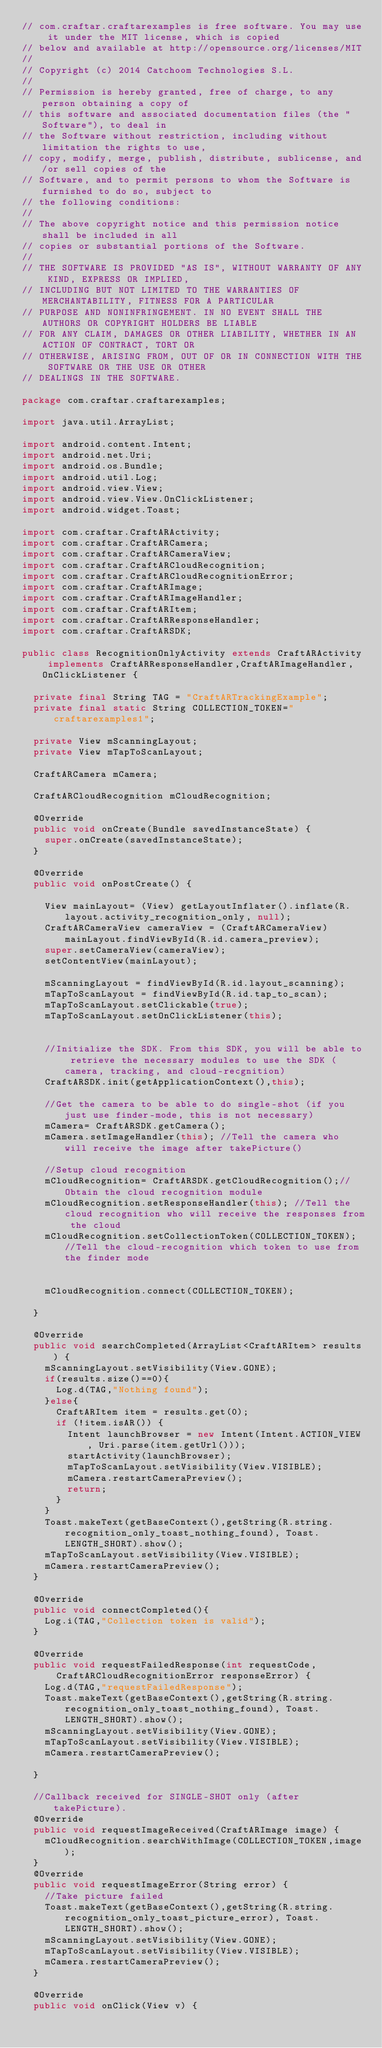Convert code to text. <code><loc_0><loc_0><loc_500><loc_500><_Java_>// com.craftar.craftarexamples is free software. You may use it under the MIT license, which is copied
// below and available at http://opensource.org/licenses/MIT
//
// Copyright (c) 2014 Catchoom Technologies S.L.
//
// Permission is hereby granted, free of charge, to any person obtaining a copy of
// this software and associated documentation files (the "Software"), to deal in
// the Software without restriction, including without limitation the rights to use,
// copy, modify, merge, publish, distribute, sublicense, and/or sell copies of the
// Software, and to permit persons to whom the Software is furnished to do so, subject to
// the following conditions:
//
// The above copyright notice and this permission notice shall be included in all
// copies or substantial portions of the Software.
//
// THE SOFTWARE IS PROVIDED "AS IS", WITHOUT WARRANTY OF ANY KIND, EXPRESS OR IMPLIED,
// INCLUDING BUT NOT LIMITED TO THE WARRANTIES OF MERCHANTABILITY, FITNESS FOR A PARTICULAR
// PURPOSE AND NONINFRINGEMENT. IN NO EVENT SHALL THE AUTHORS OR COPYRIGHT HOLDERS BE LIABLE
// FOR ANY CLAIM, DAMAGES OR OTHER LIABILITY, WHETHER IN AN ACTION OF CONTRACT, TORT OR
// OTHERWISE, ARISING FROM, OUT OF OR IN CONNECTION WITH THE SOFTWARE OR THE USE OR OTHER
// DEALINGS IN THE SOFTWARE.

package com.craftar.craftarexamples;

import java.util.ArrayList;

import android.content.Intent;
import android.net.Uri;
import android.os.Bundle;
import android.util.Log;
import android.view.View;
import android.view.View.OnClickListener;
import android.widget.Toast;

import com.craftar.CraftARActivity;
import com.craftar.CraftARCamera;
import com.craftar.CraftARCameraView;
import com.craftar.CraftARCloudRecognition;
import com.craftar.CraftARCloudRecognitionError;
import com.craftar.CraftARImage;
import com.craftar.CraftARImageHandler;
import com.craftar.CraftARItem;
import com.craftar.CraftARResponseHandler;
import com.craftar.CraftARSDK;

public class RecognitionOnlyActivity extends CraftARActivity implements CraftARResponseHandler,CraftARImageHandler, OnClickListener {

	private final String TAG = "CraftARTrackingExample";
	private final static String COLLECTION_TOKEN="craftarexamples1";

	private View mScanningLayout;
	private View mTapToScanLayout;
	
	CraftARCamera mCamera;
	
	CraftARCloudRecognition mCloudRecognition;

	@Override
	public void onCreate(Bundle savedInstanceState) {
		super.onCreate(savedInstanceState);
	}
		
	@Override
	public void onPostCreate() {
		
		View mainLayout= (View) getLayoutInflater().inflate(R.layout.activity_recognition_only, null);
		CraftARCameraView cameraView = (CraftARCameraView) mainLayout.findViewById(R.id.camera_preview);
		super.setCameraView(cameraView);
		setContentView(mainLayout);
		
		mScanningLayout = findViewById(R.id.layout_scanning);
		mTapToScanLayout = findViewById(R.id.tap_to_scan);
		mTapToScanLayout.setClickable(true);
		mTapToScanLayout.setOnClickListener(this);
		
		
		//Initialize the SDK. From this SDK, you will be able to retrieve the necessary modules to use the SDK (camera, tracking, and cloud-recgnition)
		CraftARSDK.init(getApplicationContext(),this);
		
		//Get the camera to be able to do single-shot (if you just use finder-mode, this is not necessary)
		mCamera= CraftARSDK.getCamera();
		mCamera.setImageHandler(this); //Tell the camera who will receive the image after takePicture()
		
		//Setup cloud recognition
		mCloudRecognition= CraftARSDK.getCloudRecognition();//Obtain the cloud recognition module
		mCloudRecognition.setResponseHandler(this); //Tell the cloud recognition who will receive the responses from the cloud
		mCloudRecognition.setCollectionToken(COLLECTION_TOKEN); //Tell the cloud-recognition which token to use from the finder mode
		
		
		mCloudRecognition.connect(COLLECTION_TOKEN);
		
	}
	
	@Override
	public void searchCompleted(ArrayList<CraftARItem> results) {
		mScanningLayout.setVisibility(View.GONE);
		if(results.size()==0){
			Log.d(TAG,"Nothing found");
		}else{
			CraftARItem item = results.get(0);
			if (!item.isAR()) {
				Intent launchBrowser = new Intent(Intent.ACTION_VIEW, Uri.parse(item.getUrl()));
				startActivity(launchBrowser);
				mTapToScanLayout.setVisibility(View.VISIBLE);
				mCamera.restartCameraPreview();
				return;
			}
		}
		Toast.makeText(getBaseContext(),getString(R.string.recognition_only_toast_nothing_found), Toast.LENGTH_SHORT).show();
		mTapToScanLayout.setVisibility(View.VISIBLE);
		mCamera.restartCameraPreview();
	}
	
	@Override
	public void connectCompleted(){
		Log.i(TAG,"Collection token is valid");
	}
	
	@Override
	public void requestFailedResponse(int requestCode,
			CraftARCloudRecognitionError responseError) {
		Log.d(TAG,"requestFailedResponse");	
		Toast.makeText(getBaseContext(),getString(R.string.recognition_only_toast_nothing_found), Toast.LENGTH_SHORT).show();
		mScanningLayout.setVisibility(View.GONE);
		mTapToScanLayout.setVisibility(View.VISIBLE);
		mCamera.restartCameraPreview();
		
	}

	//Callback received for SINGLE-SHOT only (after takePicture).
	@Override
	public void requestImageReceived(CraftARImage image) {
		mCloudRecognition.searchWithImage(COLLECTION_TOKEN,image);
	}
	@Override
	public void requestImageError(String error) {
		//Take picture failed
		Toast.makeText(getBaseContext(),getString(R.string.recognition_only_toast_picture_error), Toast.LENGTH_SHORT).show();
		mScanningLayout.setVisibility(View.GONE);
		mTapToScanLayout.setVisibility(View.VISIBLE);
		mCamera.restartCameraPreview();
	}

	@Override
	public void onClick(View v) {</code> 